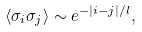Convert formula to latex. <formula><loc_0><loc_0><loc_500><loc_500>\langle \sigma _ { i } \sigma _ { j } \rangle \sim e ^ { - | i - j | / l } ,</formula> 